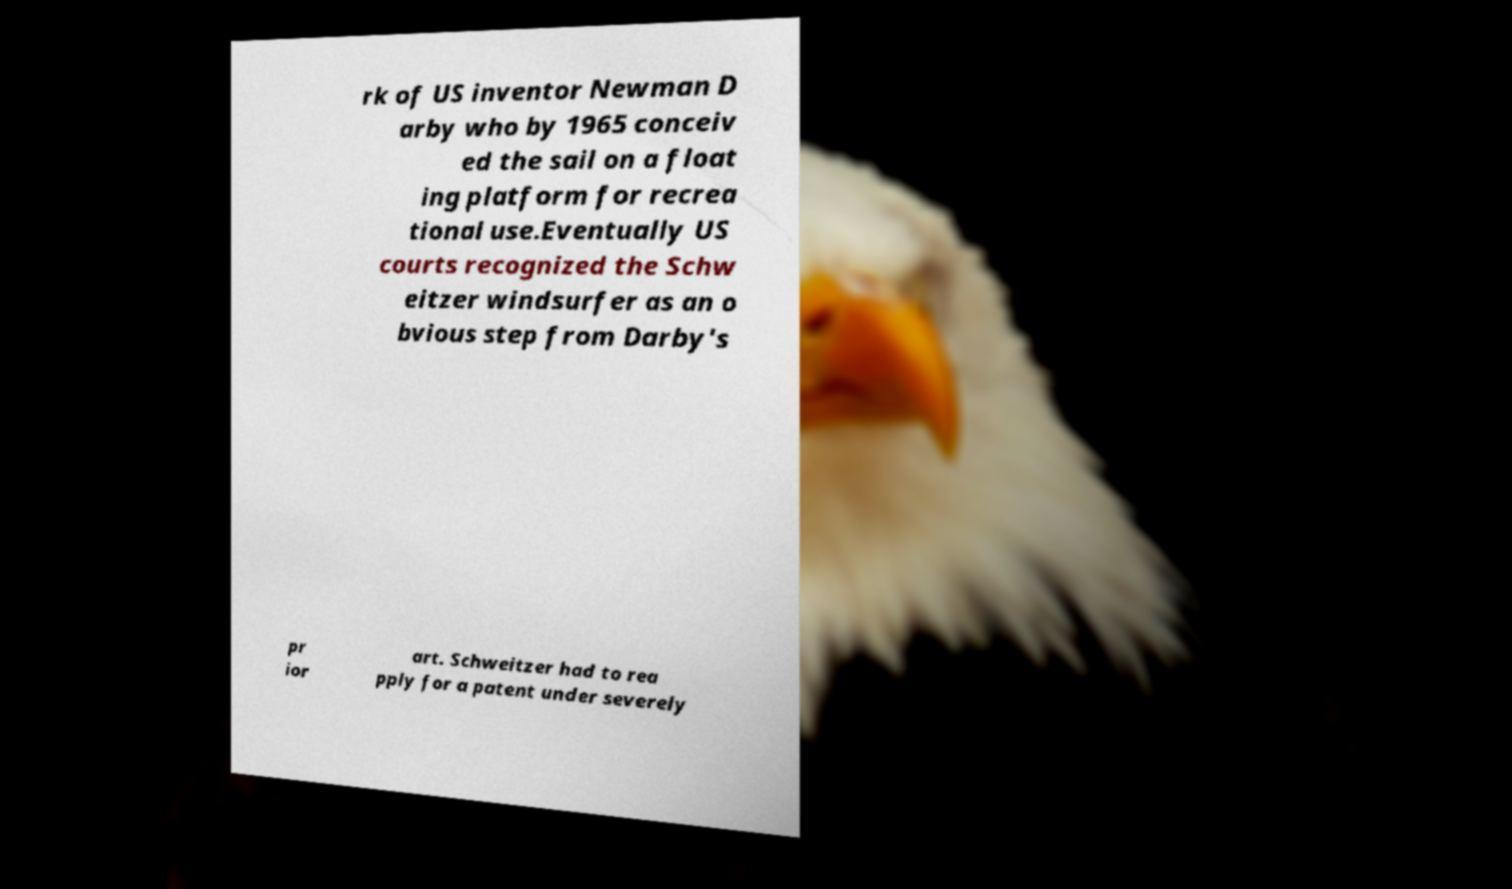Could you extract and type out the text from this image? rk of US inventor Newman D arby who by 1965 conceiv ed the sail on a float ing platform for recrea tional use.Eventually US courts recognized the Schw eitzer windsurfer as an o bvious step from Darby's pr ior art. Schweitzer had to rea pply for a patent under severely 